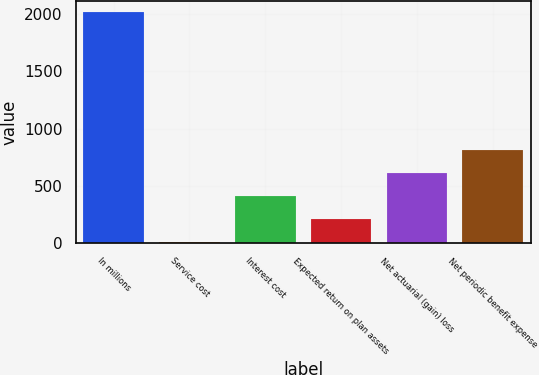Convert chart. <chart><loc_0><loc_0><loc_500><loc_500><bar_chart><fcel>In millions<fcel>Service cost<fcel>Interest cost<fcel>Expected return on plan assets<fcel>Net actuarial (gain) loss<fcel>Net periodic benefit expense<nl><fcel>2014<fcel>7.4<fcel>408.72<fcel>208.06<fcel>609.38<fcel>810.04<nl></chart> 